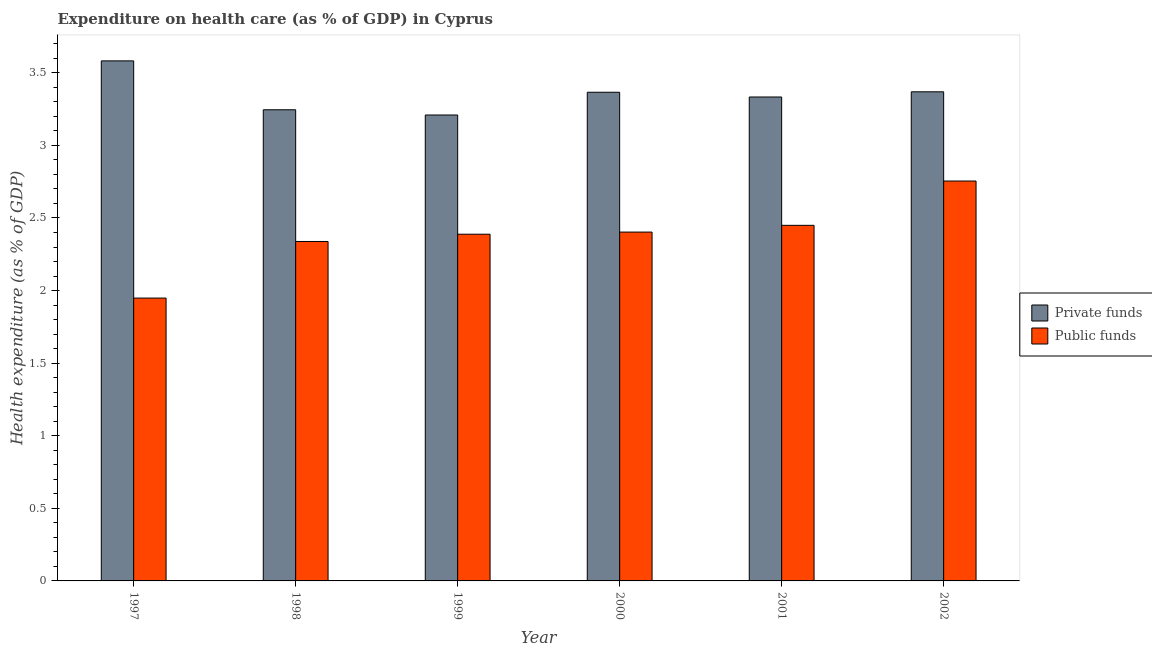How many groups of bars are there?
Keep it short and to the point. 6. How many bars are there on the 1st tick from the right?
Make the answer very short. 2. What is the label of the 3rd group of bars from the left?
Ensure brevity in your answer.  1999. In how many cases, is the number of bars for a given year not equal to the number of legend labels?
Provide a short and direct response. 0. What is the amount of private funds spent in healthcare in 1999?
Offer a terse response. 3.21. Across all years, what is the maximum amount of private funds spent in healthcare?
Your answer should be compact. 3.58. Across all years, what is the minimum amount of private funds spent in healthcare?
Offer a very short reply. 3.21. In which year was the amount of public funds spent in healthcare maximum?
Provide a succinct answer. 2002. What is the total amount of private funds spent in healthcare in the graph?
Your answer should be compact. 20.11. What is the difference between the amount of private funds spent in healthcare in 1999 and that in 2001?
Ensure brevity in your answer.  -0.12. What is the difference between the amount of public funds spent in healthcare in 1997 and the amount of private funds spent in healthcare in 2001?
Offer a very short reply. -0.5. What is the average amount of private funds spent in healthcare per year?
Ensure brevity in your answer.  3.35. In the year 2002, what is the difference between the amount of public funds spent in healthcare and amount of private funds spent in healthcare?
Your answer should be very brief. 0. In how many years, is the amount of public funds spent in healthcare greater than 2.1 %?
Your answer should be very brief. 5. What is the ratio of the amount of private funds spent in healthcare in 1998 to that in 2001?
Provide a succinct answer. 0.97. Is the amount of private funds spent in healthcare in 1997 less than that in 1999?
Your answer should be compact. No. What is the difference between the highest and the second highest amount of public funds spent in healthcare?
Provide a succinct answer. 0.31. What is the difference between the highest and the lowest amount of public funds spent in healthcare?
Give a very brief answer. 0.81. What does the 2nd bar from the left in 1998 represents?
Provide a short and direct response. Public funds. What does the 2nd bar from the right in 2002 represents?
Offer a very short reply. Private funds. How many bars are there?
Provide a short and direct response. 12. How many years are there in the graph?
Provide a succinct answer. 6. Where does the legend appear in the graph?
Offer a terse response. Center right. What is the title of the graph?
Your answer should be very brief. Expenditure on health care (as % of GDP) in Cyprus. Does "National Visitors" appear as one of the legend labels in the graph?
Keep it short and to the point. No. What is the label or title of the X-axis?
Give a very brief answer. Year. What is the label or title of the Y-axis?
Offer a very short reply. Health expenditure (as % of GDP). What is the Health expenditure (as % of GDP) of Private funds in 1997?
Provide a short and direct response. 3.58. What is the Health expenditure (as % of GDP) in Public funds in 1997?
Your answer should be compact. 1.95. What is the Health expenditure (as % of GDP) of Private funds in 1998?
Your answer should be compact. 3.25. What is the Health expenditure (as % of GDP) in Public funds in 1998?
Your response must be concise. 2.34. What is the Health expenditure (as % of GDP) in Private funds in 1999?
Keep it short and to the point. 3.21. What is the Health expenditure (as % of GDP) of Public funds in 1999?
Offer a very short reply. 2.39. What is the Health expenditure (as % of GDP) of Private funds in 2000?
Provide a succinct answer. 3.37. What is the Health expenditure (as % of GDP) of Public funds in 2000?
Keep it short and to the point. 2.4. What is the Health expenditure (as % of GDP) in Private funds in 2001?
Your response must be concise. 3.33. What is the Health expenditure (as % of GDP) in Public funds in 2001?
Provide a succinct answer. 2.45. What is the Health expenditure (as % of GDP) in Private funds in 2002?
Offer a very short reply. 3.37. What is the Health expenditure (as % of GDP) of Public funds in 2002?
Your response must be concise. 2.75. Across all years, what is the maximum Health expenditure (as % of GDP) in Private funds?
Make the answer very short. 3.58. Across all years, what is the maximum Health expenditure (as % of GDP) of Public funds?
Make the answer very short. 2.75. Across all years, what is the minimum Health expenditure (as % of GDP) in Private funds?
Offer a very short reply. 3.21. Across all years, what is the minimum Health expenditure (as % of GDP) of Public funds?
Offer a very short reply. 1.95. What is the total Health expenditure (as % of GDP) in Private funds in the graph?
Your response must be concise. 20.11. What is the total Health expenditure (as % of GDP) in Public funds in the graph?
Provide a succinct answer. 14.28. What is the difference between the Health expenditure (as % of GDP) of Private funds in 1997 and that in 1998?
Provide a succinct answer. 0.34. What is the difference between the Health expenditure (as % of GDP) in Public funds in 1997 and that in 1998?
Your answer should be compact. -0.39. What is the difference between the Health expenditure (as % of GDP) in Private funds in 1997 and that in 1999?
Make the answer very short. 0.37. What is the difference between the Health expenditure (as % of GDP) in Public funds in 1997 and that in 1999?
Provide a short and direct response. -0.44. What is the difference between the Health expenditure (as % of GDP) in Private funds in 1997 and that in 2000?
Make the answer very short. 0.22. What is the difference between the Health expenditure (as % of GDP) in Public funds in 1997 and that in 2000?
Provide a short and direct response. -0.45. What is the difference between the Health expenditure (as % of GDP) in Private funds in 1997 and that in 2001?
Offer a terse response. 0.25. What is the difference between the Health expenditure (as % of GDP) of Public funds in 1997 and that in 2001?
Your answer should be compact. -0.5. What is the difference between the Health expenditure (as % of GDP) of Private funds in 1997 and that in 2002?
Your answer should be compact. 0.21. What is the difference between the Health expenditure (as % of GDP) in Public funds in 1997 and that in 2002?
Your answer should be very brief. -0.81. What is the difference between the Health expenditure (as % of GDP) of Private funds in 1998 and that in 1999?
Give a very brief answer. 0.04. What is the difference between the Health expenditure (as % of GDP) in Private funds in 1998 and that in 2000?
Ensure brevity in your answer.  -0.12. What is the difference between the Health expenditure (as % of GDP) of Public funds in 1998 and that in 2000?
Give a very brief answer. -0.06. What is the difference between the Health expenditure (as % of GDP) of Private funds in 1998 and that in 2001?
Give a very brief answer. -0.09. What is the difference between the Health expenditure (as % of GDP) in Public funds in 1998 and that in 2001?
Offer a terse response. -0.11. What is the difference between the Health expenditure (as % of GDP) of Private funds in 1998 and that in 2002?
Ensure brevity in your answer.  -0.12. What is the difference between the Health expenditure (as % of GDP) of Public funds in 1998 and that in 2002?
Give a very brief answer. -0.42. What is the difference between the Health expenditure (as % of GDP) of Private funds in 1999 and that in 2000?
Offer a terse response. -0.16. What is the difference between the Health expenditure (as % of GDP) in Public funds in 1999 and that in 2000?
Provide a short and direct response. -0.01. What is the difference between the Health expenditure (as % of GDP) of Private funds in 1999 and that in 2001?
Ensure brevity in your answer.  -0.12. What is the difference between the Health expenditure (as % of GDP) in Public funds in 1999 and that in 2001?
Your answer should be very brief. -0.06. What is the difference between the Health expenditure (as % of GDP) of Private funds in 1999 and that in 2002?
Your answer should be compact. -0.16. What is the difference between the Health expenditure (as % of GDP) of Public funds in 1999 and that in 2002?
Your answer should be compact. -0.37. What is the difference between the Health expenditure (as % of GDP) of Private funds in 2000 and that in 2001?
Offer a very short reply. 0.03. What is the difference between the Health expenditure (as % of GDP) of Public funds in 2000 and that in 2001?
Your answer should be very brief. -0.05. What is the difference between the Health expenditure (as % of GDP) of Private funds in 2000 and that in 2002?
Provide a succinct answer. -0. What is the difference between the Health expenditure (as % of GDP) in Public funds in 2000 and that in 2002?
Give a very brief answer. -0.35. What is the difference between the Health expenditure (as % of GDP) of Private funds in 2001 and that in 2002?
Offer a terse response. -0.04. What is the difference between the Health expenditure (as % of GDP) of Public funds in 2001 and that in 2002?
Offer a terse response. -0.31. What is the difference between the Health expenditure (as % of GDP) in Private funds in 1997 and the Health expenditure (as % of GDP) in Public funds in 1998?
Your response must be concise. 1.24. What is the difference between the Health expenditure (as % of GDP) of Private funds in 1997 and the Health expenditure (as % of GDP) of Public funds in 1999?
Ensure brevity in your answer.  1.19. What is the difference between the Health expenditure (as % of GDP) in Private funds in 1997 and the Health expenditure (as % of GDP) in Public funds in 2000?
Ensure brevity in your answer.  1.18. What is the difference between the Health expenditure (as % of GDP) in Private funds in 1997 and the Health expenditure (as % of GDP) in Public funds in 2001?
Give a very brief answer. 1.13. What is the difference between the Health expenditure (as % of GDP) in Private funds in 1997 and the Health expenditure (as % of GDP) in Public funds in 2002?
Give a very brief answer. 0.83. What is the difference between the Health expenditure (as % of GDP) in Private funds in 1998 and the Health expenditure (as % of GDP) in Public funds in 1999?
Provide a short and direct response. 0.86. What is the difference between the Health expenditure (as % of GDP) in Private funds in 1998 and the Health expenditure (as % of GDP) in Public funds in 2000?
Provide a short and direct response. 0.84. What is the difference between the Health expenditure (as % of GDP) of Private funds in 1998 and the Health expenditure (as % of GDP) of Public funds in 2001?
Provide a succinct answer. 0.8. What is the difference between the Health expenditure (as % of GDP) of Private funds in 1998 and the Health expenditure (as % of GDP) of Public funds in 2002?
Your answer should be very brief. 0.49. What is the difference between the Health expenditure (as % of GDP) of Private funds in 1999 and the Health expenditure (as % of GDP) of Public funds in 2000?
Make the answer very short. 0.81. What is the difference between the Health expenditure (as % of GDP) of Private funds in 1999 and the Health expenditure (as % of GDP) of Public funds in 2001?
Give a very brief answer. 0.76. What is the difference between the Health expenditure (as % of GDP) of Private funds in 1999 and the Health expenditure (as % of GDP) of Public funds in 2002?
Your response must be concise. 0.45. What is the difference between the Health expenditure (as % of GDP) of Private funds in 2000 and the Health expenditure (as % of GDP) of Public funds in 2001?
Ensure brevity in your answer.  0.92. What is the difference between the Health expenditure (as % of GDP) in Private funds in 2000 and the Health expenditure (as % of GDP) in Public funds in 2002?
Keep it short and to the point. 0.61. What is the difference between the Health expenditure (as % of GDP) in Private funds in 2001 and the Health expenditure (as % of GDP) in Public funds in 2002?
Keep it short and to the point. 0.58. What is the average Health expenditure (as % of GDP) in Private funds per year?
Your answer should be compact. 3.35. What is the average Health expenditure (as % of GDP) of Public funds per year?
Ensure brevity in your answer.  2.38. In the year 1997, what is the difference between the Health expenditure (as % of GDP) of Private funds and Health expenditure (as % of GDP) of Public funds?
Your answer should be compact. 1.63. In the year 1998, what is the difference between the Health expenditure (as % of GDP) in Private funds and Health expenditure (as % of GDP) in Public funds?
Give a very brief answer. 0.91. In the year 1999, what is the difference between the Health expenditure (as % of GDP) of Private funds and Health expenditure (as % of GDP) of Public funds?
Your response must be concise. 0.82. In the year 2000, what is the difference between the Health expenditure (as % of GDP) of Private funds and Health expenditure (as % of GDP) of Public funds?
Offer a very short reply. 0.96. In the year 2001, what is the difference between the Health expenditure (as % of GDP) of Private funds and Health expenditure (as % of GDP) of Public funds?
Your response must be concise. 0.88. In the year 2002, what is the difference between the Health expenditure (as % of GDP) of Private funds and Health expenditure (as % of GDP) of Public funds?
Offer a very short reply. 0.61. What is the ratio of the Health expenditure (as % of GDP) in Private funds in 1997 to that in 1998?
Your answer should be compact. 1.1. What is the ratio of the Health expenditure (as % of GDP) of Private funds in 1997 to that in 1999?
Give a very brief answer. 1.12. What is the ratio of the Health expenditure (as % of GDP) in Public funds in 1997 to that in 1999?
Your answer should be very brief. 0.82. What is the ratio of the Health expenditure (as % of GDP) of Private funds in 1997 to that in 2000?
Provide a succinct answer. 1.06. What is the ratio of the Health expenditure (as % of GDP) of Public funds in 1997 to that in 2000?
Your response must be concise. 0.81. What is the ratio of the Health expenditure (as % of GDP) in Private funds in 1997 to that in 2001?
Make the answer very short. 1.07. What is the ratio of the Health expenditure (as % of GDP) in Public funds in 1997 to that in 2001?
Your answer should be compact. 0.8. What is the ratio of the Health expenditure (as % of GDP) in Private funds in 1997 to that in 2002?
Your response must be concise. 1.06. What is the ratio of the Health expenditure (as % of GDP) of Public funds in 1997 to that in 2002?
Give a very brief answer. 0.71. What is the ratio of the Health expenditure (as % of GDP) of Private funds in 1998 to that in 1999?
Provide a short and direct response. 1.01. What is the ratio of the Health expenditure (as % of GDP) in Public funds in 1998 to that in 1999?
Your response must be concise. 0.98. What is the ratio of the Health expenditure (as % of GDP) of Private funds in 1998 to that in 2000?
Offer a very short reply. 0.96. What is the ratio of the Health expenditure (as % of GDP) of Public funds in 1998 to that in 2000?
Offer a terse response. 0.97. What is the ratio of the Health expenditure (as % of GDP) in Private funds in 1998 to that in 2001?
Ensure brevity in your answer.  0.97. What is the ratio of the Health expenditure (as % of GDP) of Public funds in 1998 to that in 2001?
Give a very brief answer. 0.95. What is the ratio of the Health expenditure (as % of GDP) in Private funds in 1998 to that in 2002?
Give a very brief answer. 0.96. What is the ratio of the Health expenditure (as % of GDP) of Public funds in 1998 to that in 2002?
Provide a short and direct response. 0.85. What is the ratio of the Health expenditure (as % of GDP) in Private funds in 1999 to that in 2000?
Offer a very short reply. 0.95. What is the ratio of the Health expenditure (as % of GDP) in Public funds in 1999 to that in 2000?
Provide a succinct answer. 0.99. What is the ratio of the Health expenditure (as % of GDP) in Private funds in 1999 to that in 2001?
Keep it short and to the point. 0.96. What is the ratio of the Health expenditure (as % of GDP) in Public funds in 1999 to that in 2001?
Offer a terse response. 0.97. What is the ratio of the Health expenditure (as % of GDP) of Private funds in 1999 to that in 2002?
Keep it short and to the point. 0.95. What is the ratio of the Health expenditure (as % of GDP) of Public funds in 1999 to that in 2002?
Ensure brevity in your answer.  0.87. What is the ratio of the Health expenditure (as % of GDP) in Private funds in 2000 to that in 2001?
Your response must be concise. 1.01. What is the ratio of the Health expenditure (as % of GDP) of Public funds in 2000 to that in 2001?
Give a very brief answer. 0.98. What is the ratio of the Health expenditure (as % of GDP) of Private funds in 2000 to that in 2002?
Give a very brief answer. 1. What is the ratio of the Health expenditure (as % of GDP) of Public funds in 2000 to that in 2002?
Your answer should be very brief. 0.87. What is the ratio of the Health expenditure (as % of GDP) in Private funds in 2001 to that in 2002?
Make the answer very short. 0.99. What is the ratio of the Health expenditure (as % of GDP) of Public funds in 2001 to that in 2002?
Your answer should be very brief. 0.89. What is the difference between the highest and the second highest Health expenditure (as % of GDP) of Private funds?
Make the answer very short. 0.21. What is the difference between the highest and the second highest Health expenditure (as % of GDP) of Public funds?
Give a very brief answer. 0.31. What is the difference between the highest and the lowest Health expenditure (as % of GDP) of Private funds?
Provide a short and direct response. 0.37. What is the difference between the highest and the lowest Health expenditure (as % of GDP) in Public funds?
Make the answer very short. 0.81. 